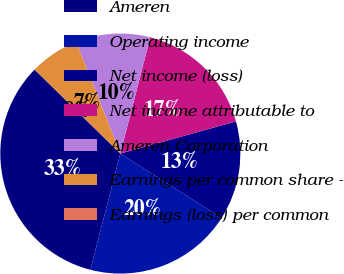Convert chart to OTSL. <chart><loc_0><loc_0><loc_500><loc_500><pie_chart><fcel>Ameren<fcel>Operating income<fcel>Net income (loss)<fcel>Net income attributable to<fcel>Ameren Corporation<fcel>Earnings per common share -<fcel>Earnings (loss) per common<nl><fcel>33.32%<fcel>20.0%<fcel>13.33%<fcel>16.67%<fcel>10.0%<fcel>6.67%<fcel>0.01%<nl></chart> 